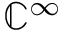Convert formula to latex. <formula><loc_0><loc_0><loc_500><loc_500>\mathbb { C } ^ { \infty }</formula> 